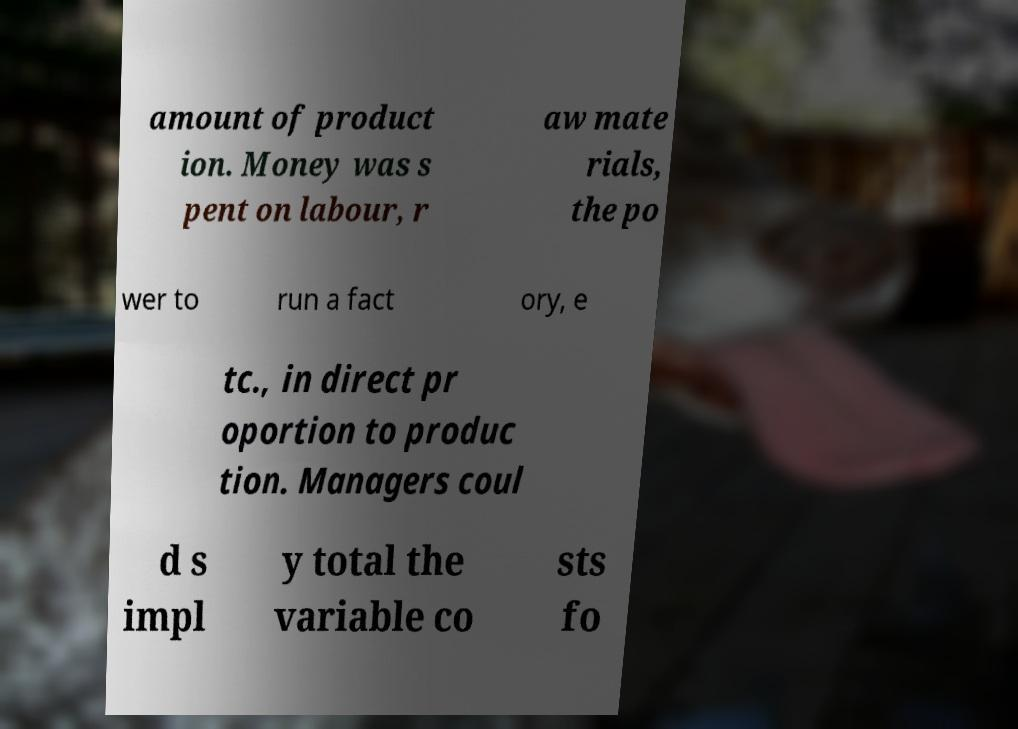Could you assist in decoding the text presented in this image and type it out clearly? amount of product ion. Money was s pent on labour, r aw mate rials, the po wer to run a fact ory, e tc., in direct pr oportion to produc tion. Managers coul d s impl y total the variable co sts fo 